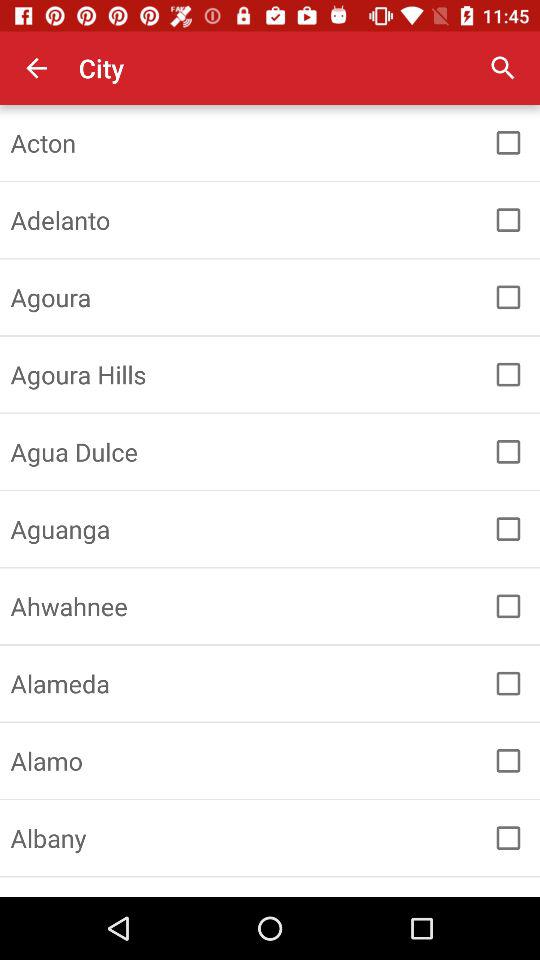Is Alamo checked or unchecked? The Alamo is unchecked. 